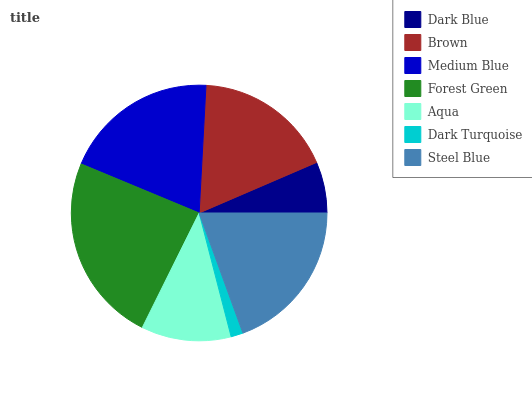Is Dark Turquoise the minimum?
Answer yes or no. Yes. Is Forest Green the maximum?
Answer yes or no. Yes. Is Brown the minimum?
Answer yes or no. No. Is Brown the maximum?
Answer yes or no. No. Is Brown greater than Dark Blue?
Answer yes or no. Yes. Is Dark Blue less than Brown?
Answer yes or no. Yes. Is Dark Blue greater than Brown?
Answer yes or no. No. Is Brown less than Dark Blue?
Answer yes or no. No. Is Brown the high median?
Answer yes or no. Yes. Is Brown the low median?
Answer yes or no. Yes. Is Dark Blue the high median?
Answer yes or no. No. Is Dark Blue the low median?
Answer yes or no. No. 